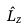Convert formula to latex. <formula><loc_0><loc_0><loc_500><loc_500>\hat { L } _ { z }</formula> 